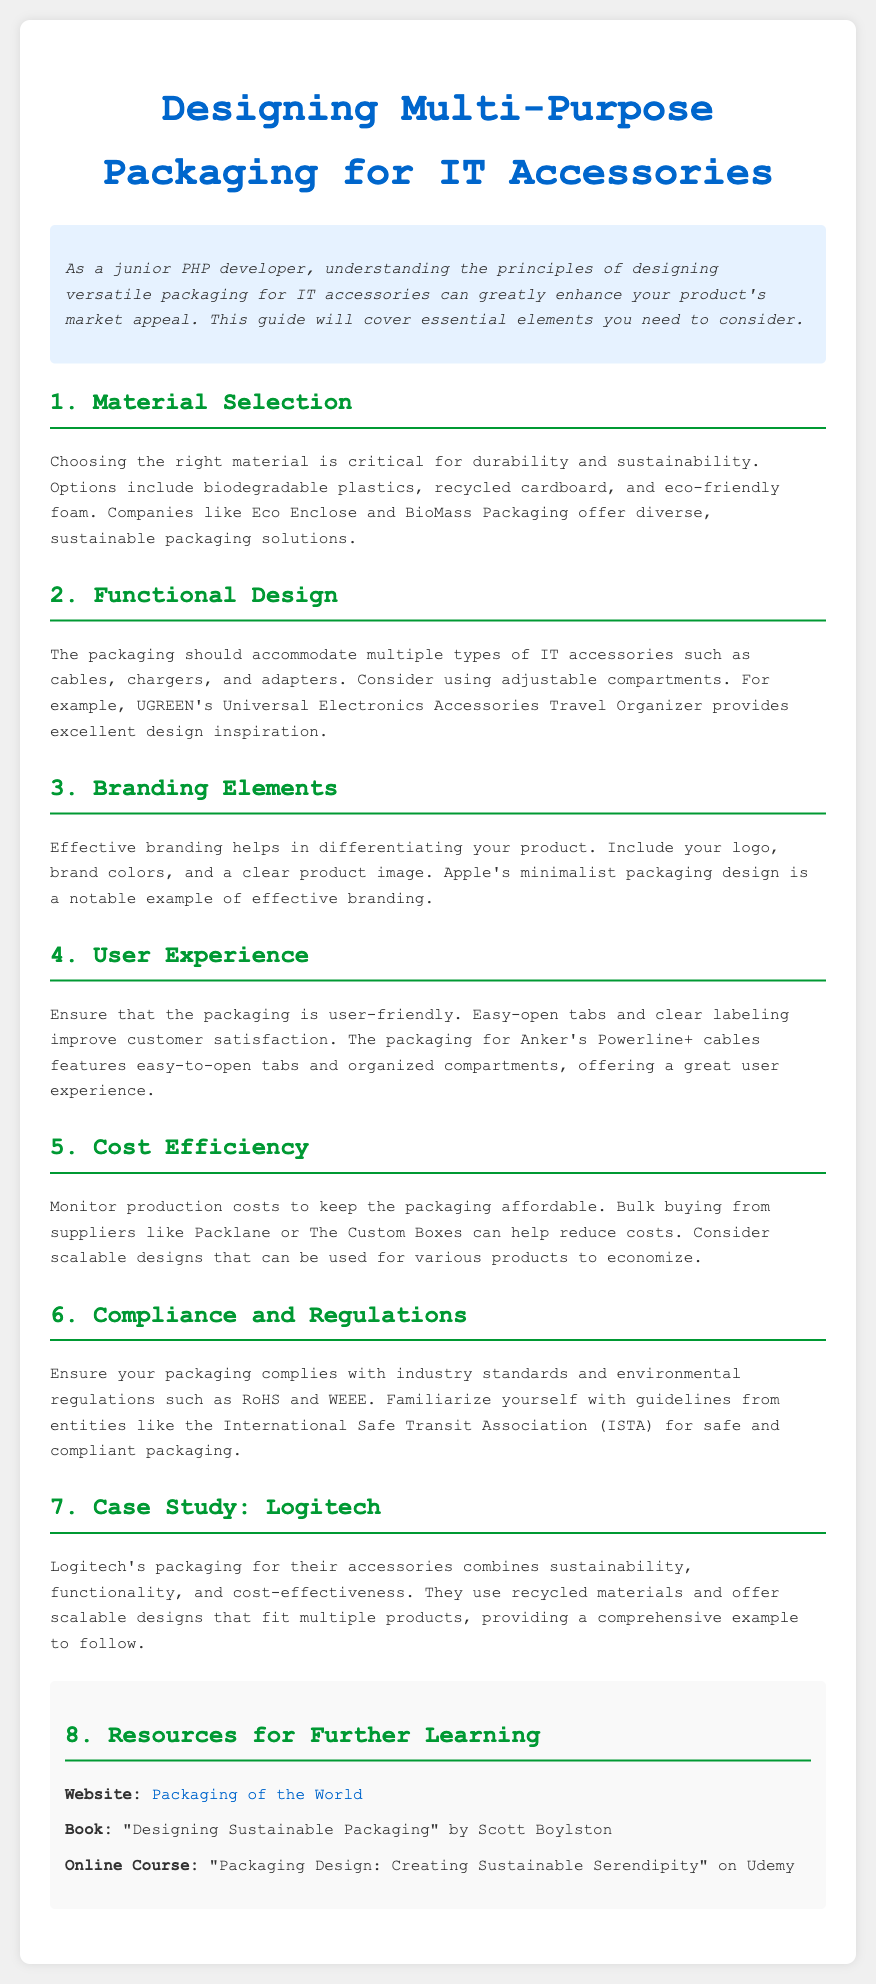what is the title of the document? The title of the document is specified in the `<title>` tag of the HTML, saying the purpose of the document.
Answer: Designing Multi-Purpose Packaging for IT Accessories what type of materials are suggested for packaging? The document lists several types of materials suitable for packaging in the section about Material Selection.
Answer: Biodegradable plastics, recycled cardboard, eco-friendly foam who is a notable example of effective branding? The section on Branding Elements mentions a specific company known for its packaging design.
Answer: Apple what should the packaging accommodate? The Functional Design section indicates the types of items that the packaging should hold.
Answer: Cables, chargers, adapters which company’s packaging features easy-open tabs? The document provides an example of a product with user-friendly packaging.
Answer: Anker what is one way to reduce production costs? The section on Cost Efficiency discusses strategies for managing expenses in packaging production.
Answer: Bulk buying what packaging case study is mentioned in the document? The document includes a specific example that showcases effective packaging practices.
Answer: Logitech what is the name of the book listed in the resources? The resources section offers a title of a book for further learning about packaging design.
Answer: Designing Sustainable Packaging what online course is recommended? The document lists a specific online course available for learning about sustainable packaging design.
Answer: Packaging Design: Creating Sustainable Serendipity 